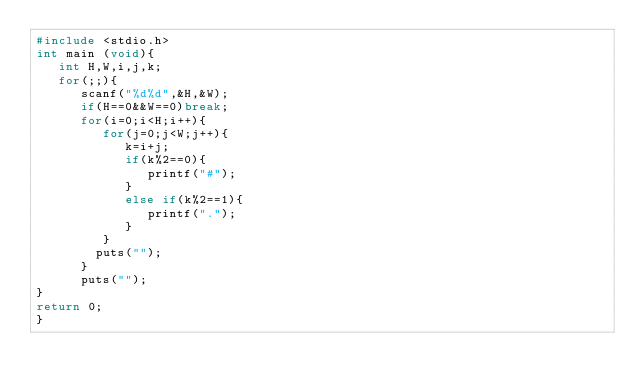<code> <loc_0><loc_0><loc_500><loc_500><_C_>#include <stdio.h>
int main (void){
   int H,W,i,j,k;
   for(;;){
      scanf("%d%d",&H,&W);
      if(H==0&&W==0)break;
      for(i=0;i<H;i++){
         for(j=0;j<W;j++){
            k=i+j;
            if(k%2==0){
               printf("#");
            }
            else if(k%2==1){
               printf(".");
            }
         }
        puts("");
      }
      puts("");
}
return 0;
}</code> 